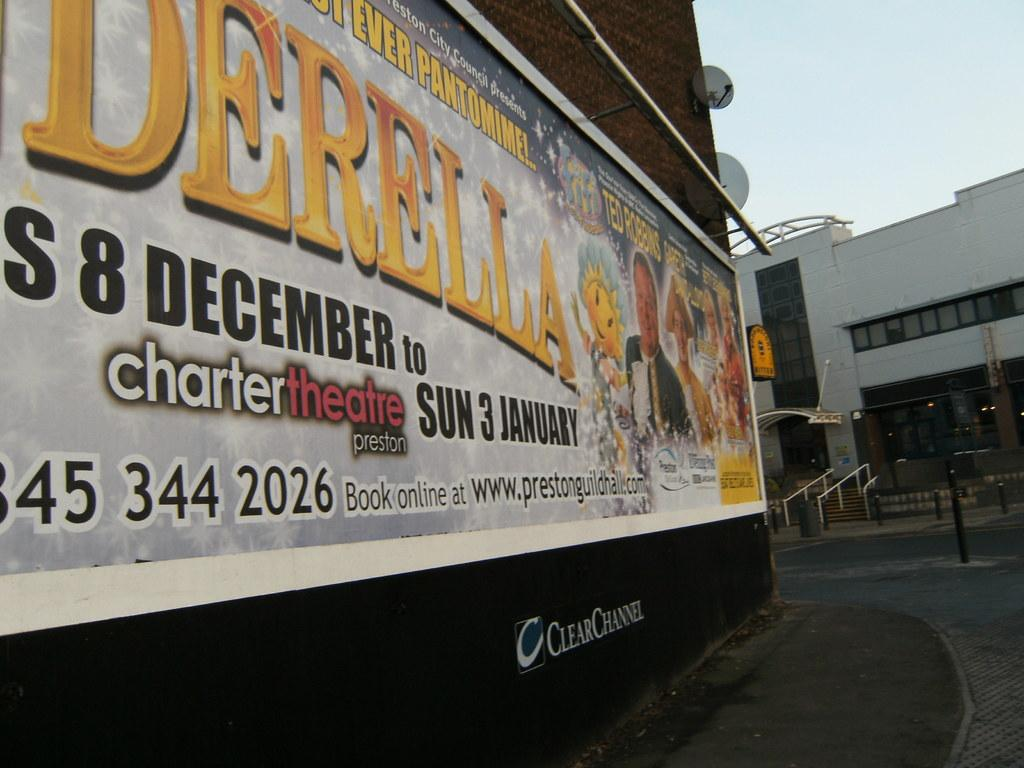What is the main object in the image? There is a board in the image. What is attached to the board? A banner is present on the board. What can be read on the banner? There is text on the banner. What is visible on the right side of the image? There is a building on the right side of the image. What is visible at the top of the image? The sky is visible at the top of the image. Where is the goat located in the image? There is no goat present in the image. How does the mine affect the building in the image? There is no mine present in the image, so it cannot affect the building. 